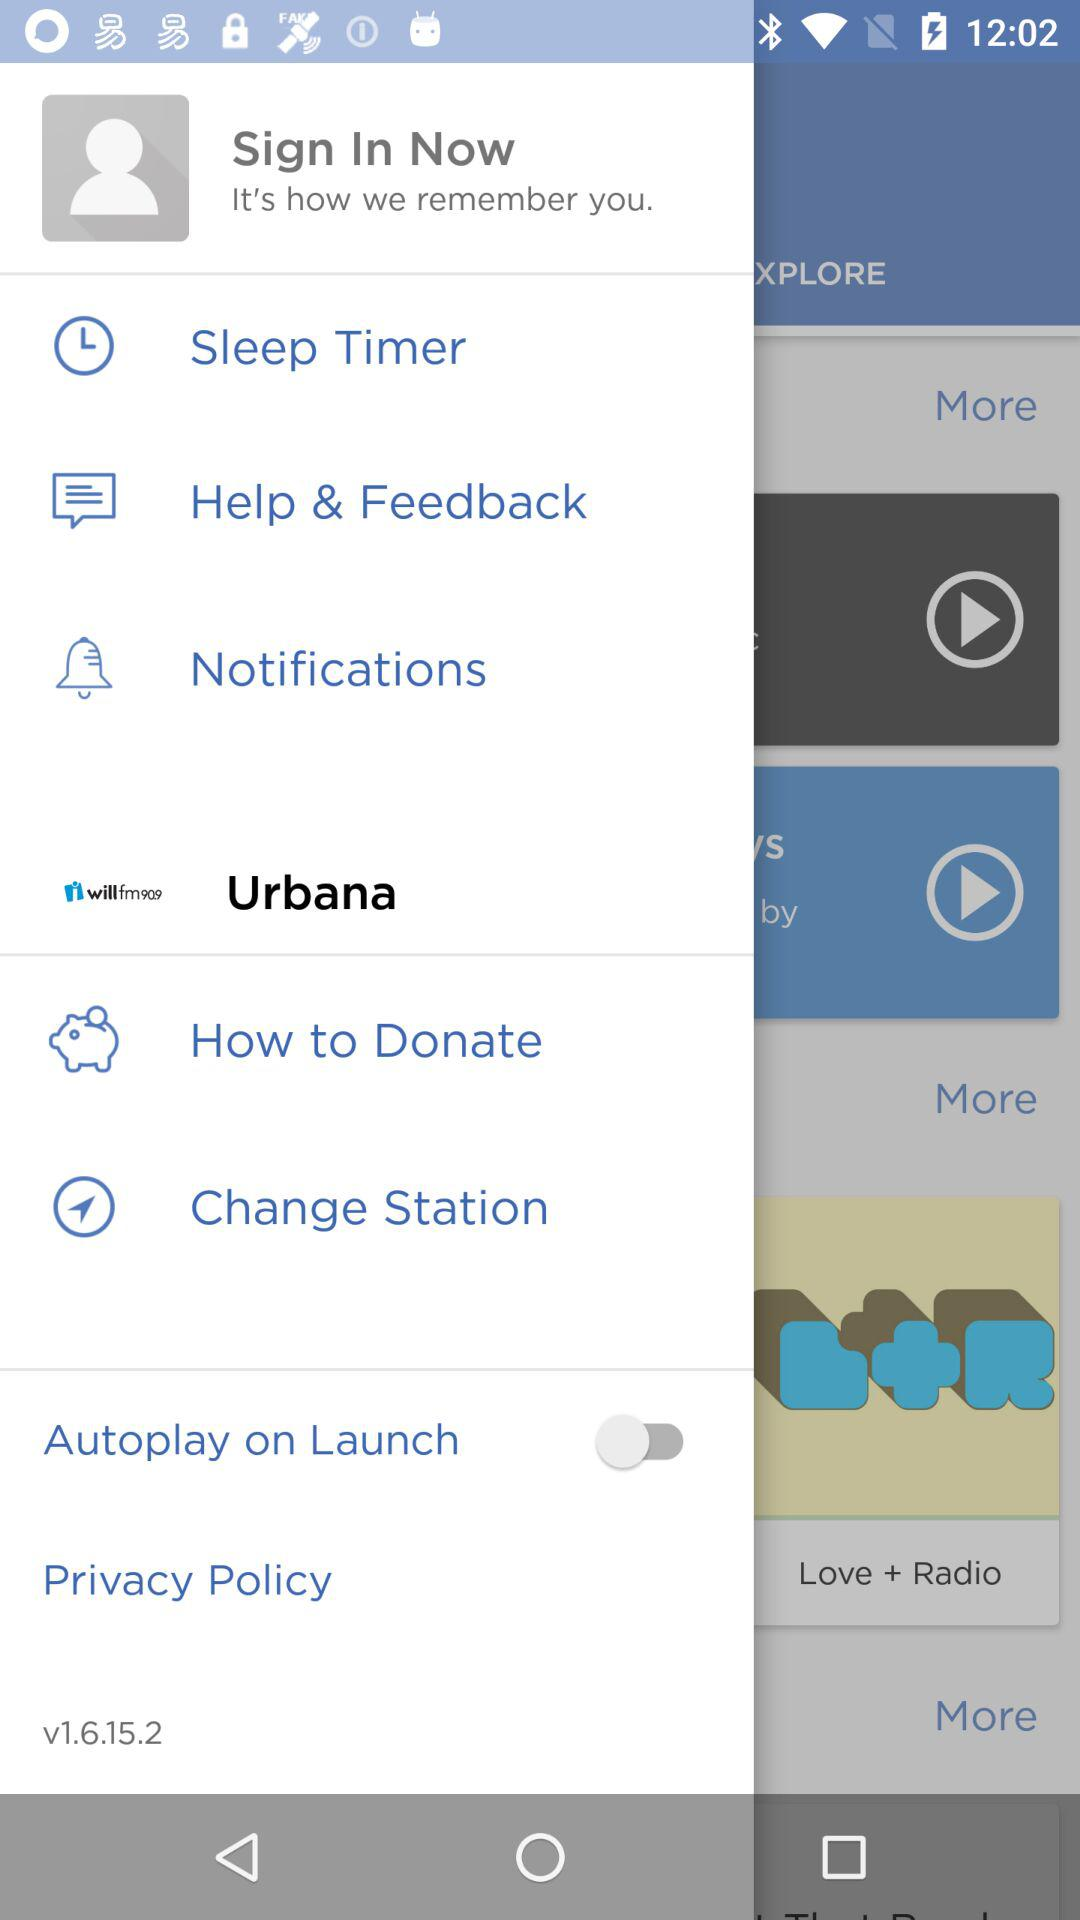What is the status of "Autoplay on Launch"? The status is "off". 